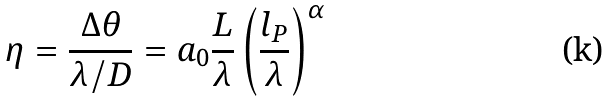<formula> <loc_0><loc_0><loc_500><loc_500>\eta = \frac { \Delta \theta } { \lambda / D } = a _ { 0 } \frac { L } { \lambda } \left ( \frac { l _ { P } } { \lambda } \right ) ^ { \alpha }</formula> 